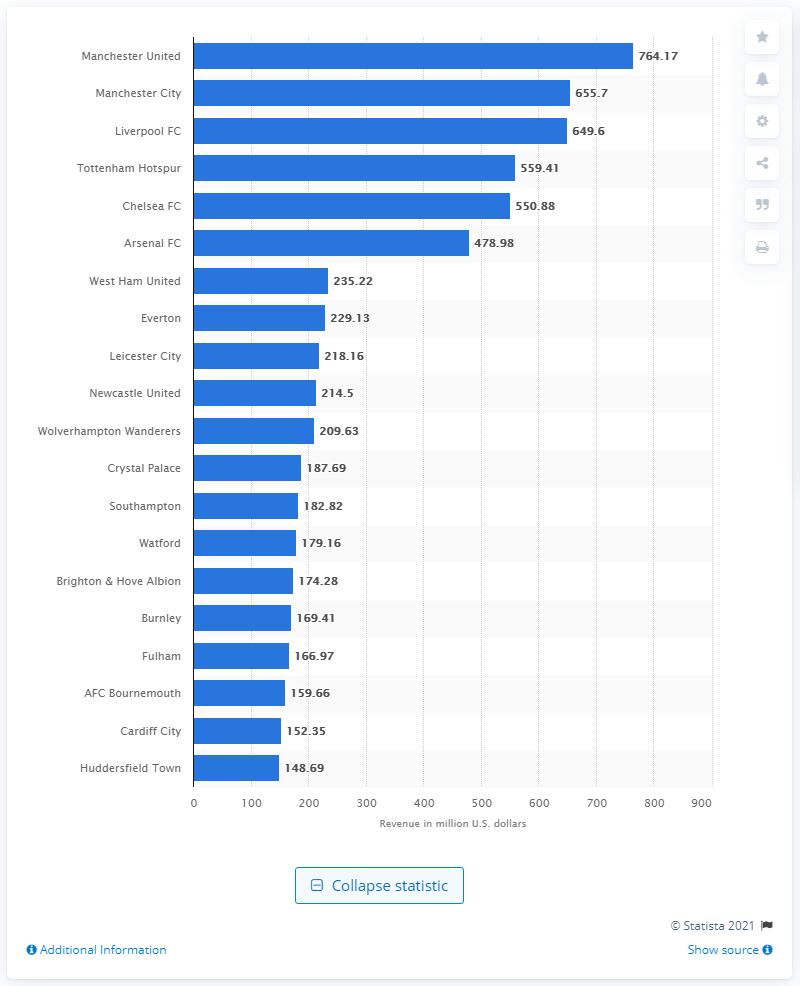Outline some significant characteristics in this image. The Manchester United generated a staggering £764.17 million in revenue during the 2018/19 season, cementing their position as one of the wealthiest and most successful football clubs in the world. 